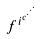<formula> <loc_0><loc_0><loc_500><loc_500>f ^ { i ^ { c ^ { \cdot ^ { \cdot ^ { \cdot } } } } }</formula> 